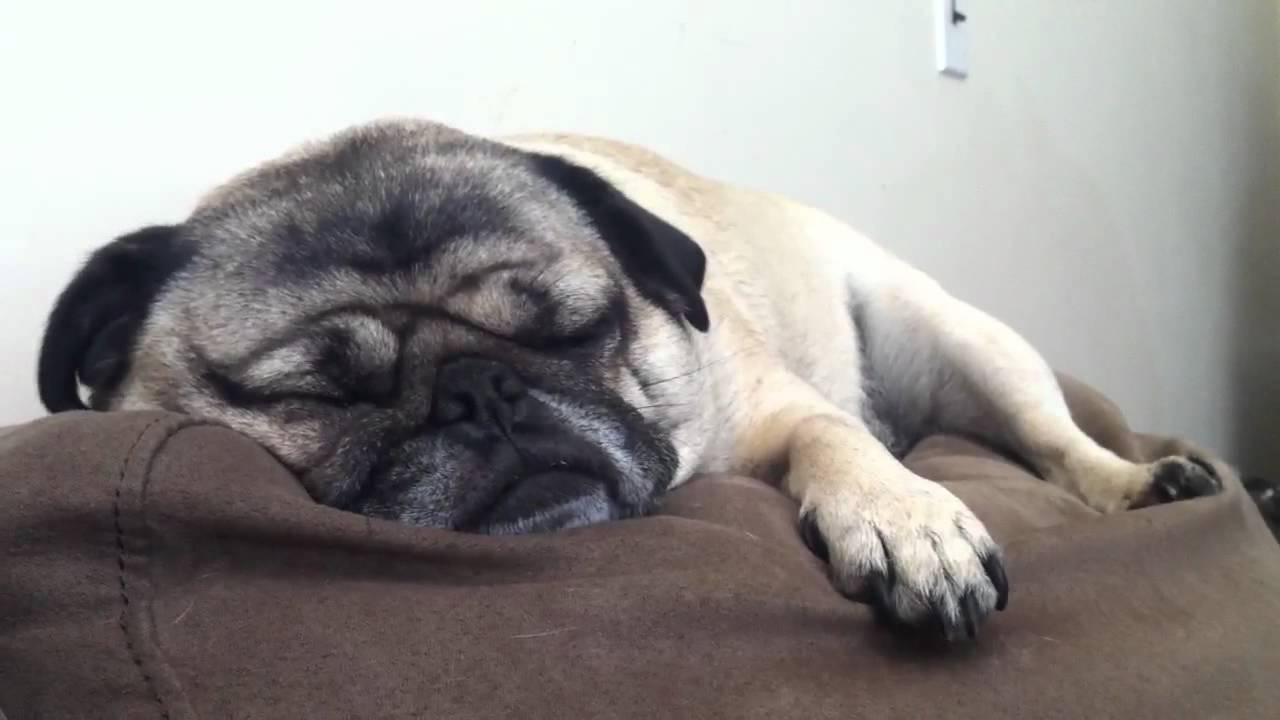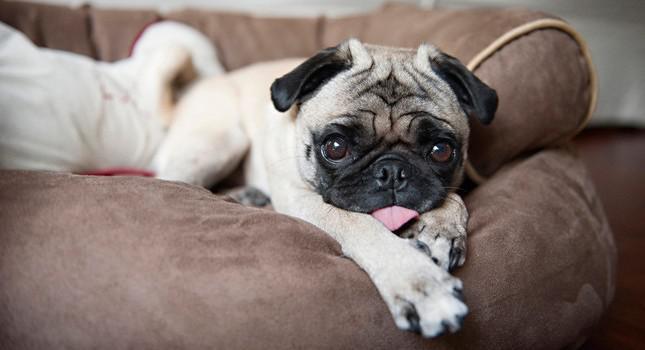The first image is the image on the left, the second image is the image on the right. Analyze the images presented: Is the assertion "Not one of the dogs is laying on a sofa." valid? Answer yes or no. No. The first image is the image on the left, the second image is the image on the right. Considering the images on both sides, is "Each image shows one dog lounging on a soft cushioned surface." valid? Answer yes or no. Yes. 